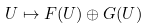Convert formula to latex. <formula><loc_0><loc_0><loc_500><loc_500>U \mapsto F ( U ) \oplus G ( U )</formula> 